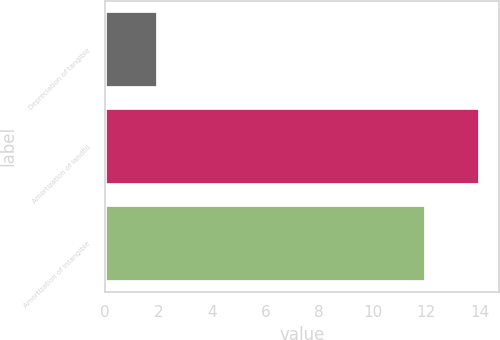Convert chart. <chart><loc_0><loc_0><loc_500><loc_500><bar_chart><fcel>Depreciation of tangible<fcel>Amortization of landfill<fcel>Amortization of intangible<nl><fcel>2<fcel>14<fcel>12<nl></chart> 